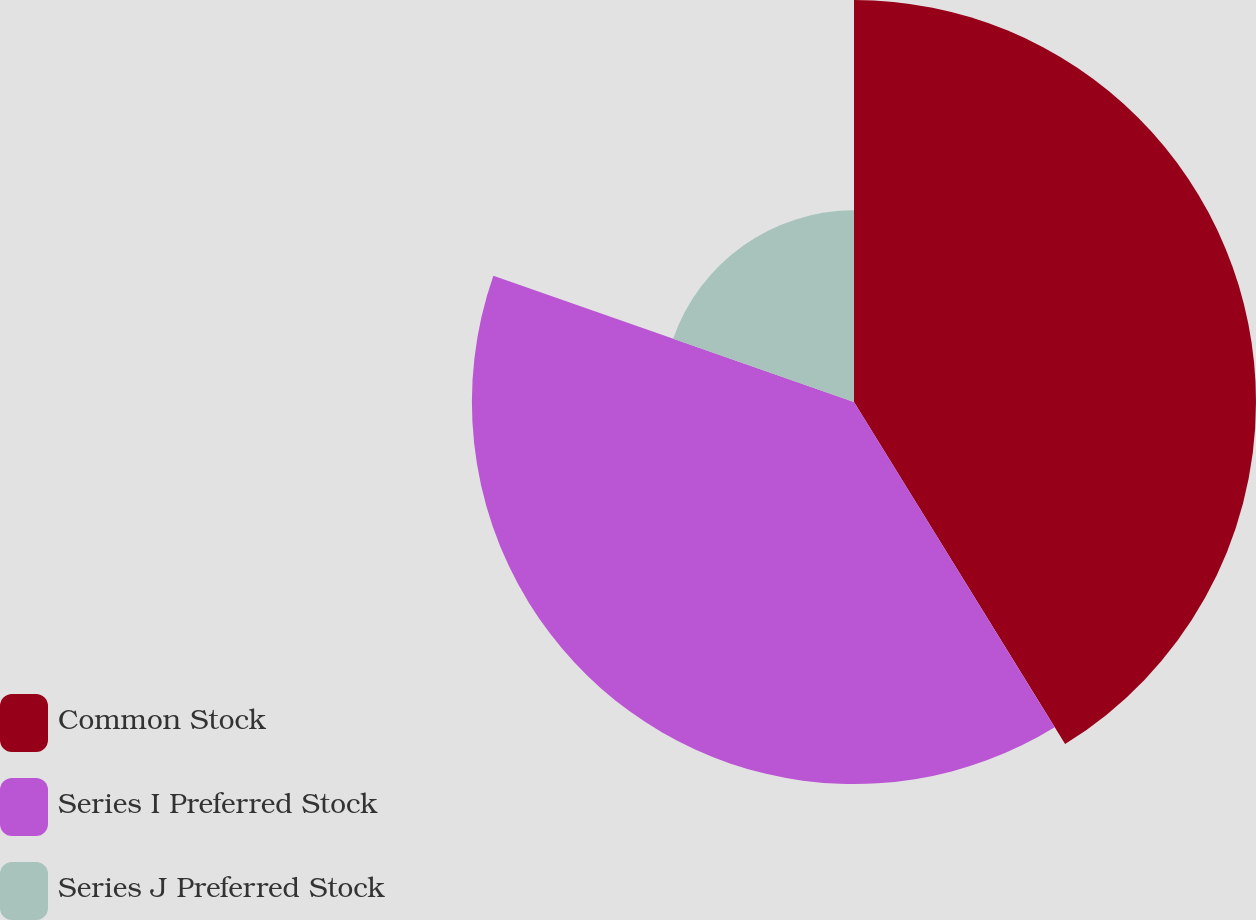<chart> <loc_0><loc_0><loc_500><loc_500><pie_chart><fcel>Common Stock<fcel>Series I Preferred Stock<fcel>Series J Preferred Stock<nl><fcel>41.2%<fcel>39.16%<fcel>19.64%<nl></chart> 